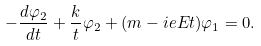<formula> <loc_0><loc_0><loc_500><loc_500>- \frac { d \varphi _ { 2 } } { d t } + \frac { k } { t } \varphi _ { 2 } + ( m - i e E t ) \varphi _ { 1 } = 0 .</formula> 